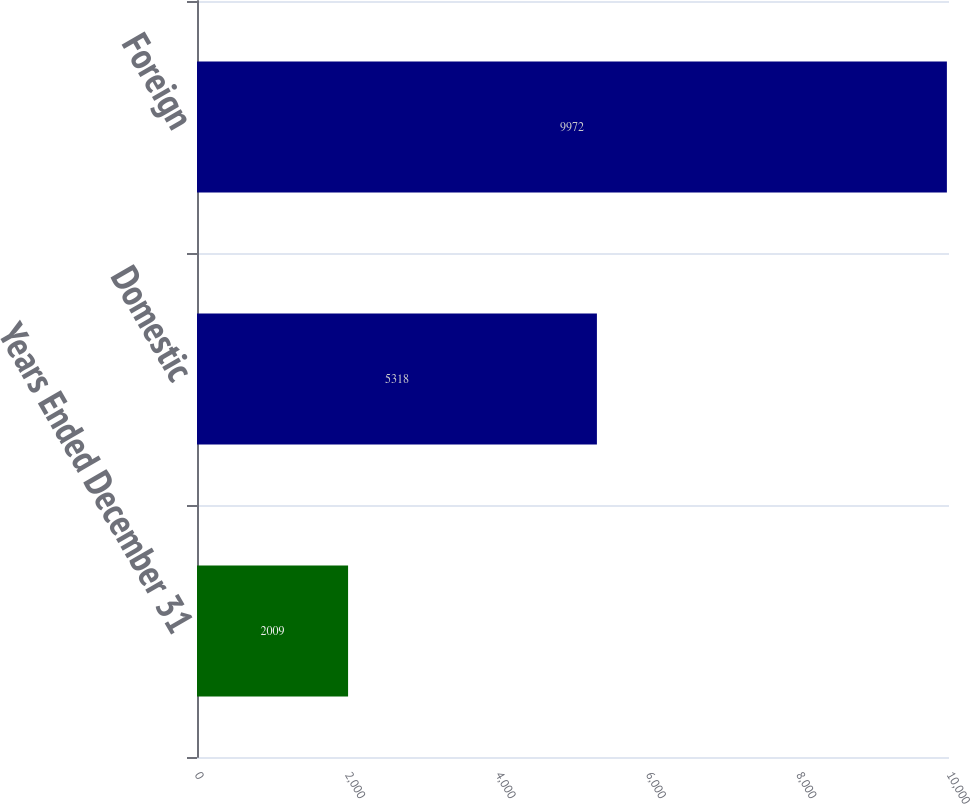Convert chart. <chart><loc_0><loc_0><loc_500><loc_500><bar_chart><fcel>Years Ended December 31<fcel>Domestic<fcel>Foreign<nl><fcel>2009<fcel>5318<fcel>9972<nl></chart> 